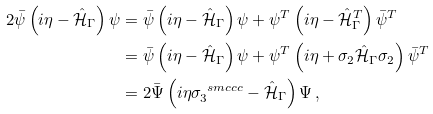Convert formula to latex. <formula><loc_0><loc_0><loc_500><loc_500>2 \bar { \psi } \left ( i \eta - \hat { \mathcal { H } } _ { \Gamma } \right ) \psi & = \bar { \psi } \left ( i \eta - \hat { \mathcal { H } } _ { \Gamma } \right ) \psi + \psi ^ { T } \left ( i \eta - \hat { \mathcal { H } } _ { \Gamma } ^ { T } \right ) \bar { \psi } ^ { T } \\ & = \bar { \psi } \left ( i \eta - \hat { \mathcal { H } } _ { \Gamma } \right ) \psi + \psi ^ { T } \left ( i \eta + \sigma _ { 2 } \hat { \mathcal { H } } _ { \Gamma } \sigma _ { 2 } \right ) \bar { \psi } ^ { T } \\ & = 2 \bar { \Psi } \left ( i \eta \sigma ^ { \ s m c { c c } } _ { 3 } - \hat { \mathcal { H } } _ { \Gamma } \right ) \Psi \, ,</formula> 